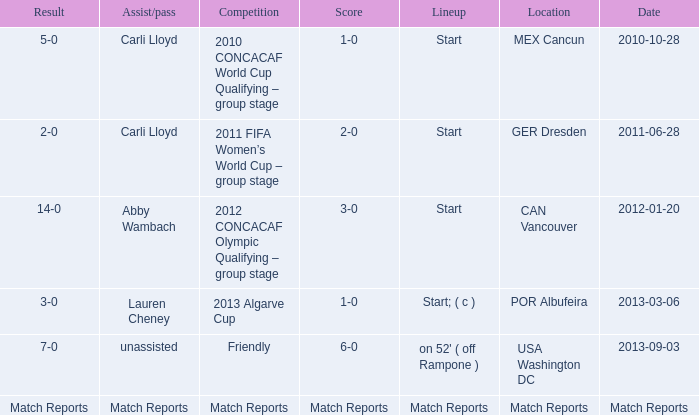Which score has a competition of match reports? Match Reports. 